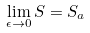Convert formula to latex. <formula><loc_0><loc_0><loc_500><loc_500>\lim _ { \epsilon \rightarrow 0 } S = S _ { a }</formula> 